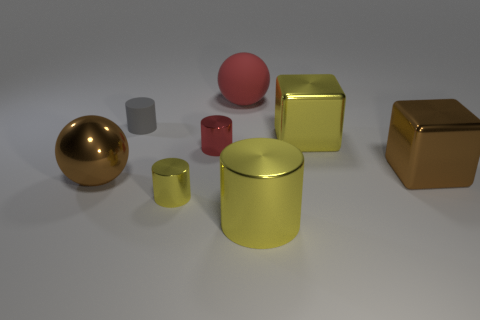There is a metal cylinder that is behind the large metallic sphere; is its size the same as the gray matte object that is left of the red rubber thing?
Provide a short and direct response. Yes. What number of other objects are there of the same material as the red cylinder?
Your answer should be compact. 5. What number of matte things are either tiny cylinders or small blue spheres?
Provide a succinct answer. 1. Is the number of large brown cubes less than the number of red rubber cylinders?
Provide a short and direct response. No. There is a matte ball; does it have the same size as the yellow object that is behind the metallic ball?
Offer a very short reply. Yes. Is there any other thing that is the same shape as the red rubber object?
Your response must be concise. Yes. What is the size of the yellow cube?
Your answer should be very brief. Large. Are there fewer large cylinders that are behind the red metallic thing than metallic balls?
Your response must be concise. Yes. Does the red metallic thing have the same size as the red sphere?
Provide a succinct answer. No. Is there anything else that has the same size as the matte ball?
Offer a very short reply. Yes. 